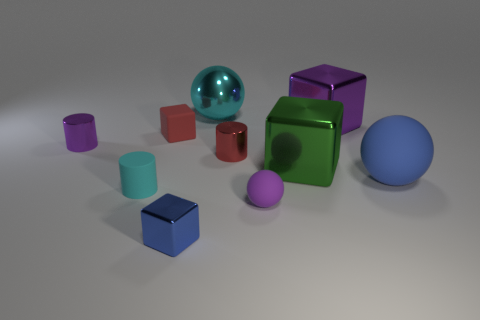Subtract all spheres. How many objects are left? 7 Subtract 0 yellow cylinders. How many objects are left? 10 Subtract all large green objects. Subtract all blue balls. How many objects are left? 8 Add 6 tiny red shiny cylinders. How many tiny red shiny cylinders are left? 7 Add 10 red shiny balls. How many red shiny balls exist? 10 